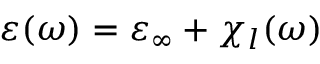Convert formula to latex. <formula><loc_0><loc_0><loc_500><loc_500>\varepsilon ( \omega ) = \varepsilon _ { \infty } + \chi _ { l } ( \omega )</formula> 